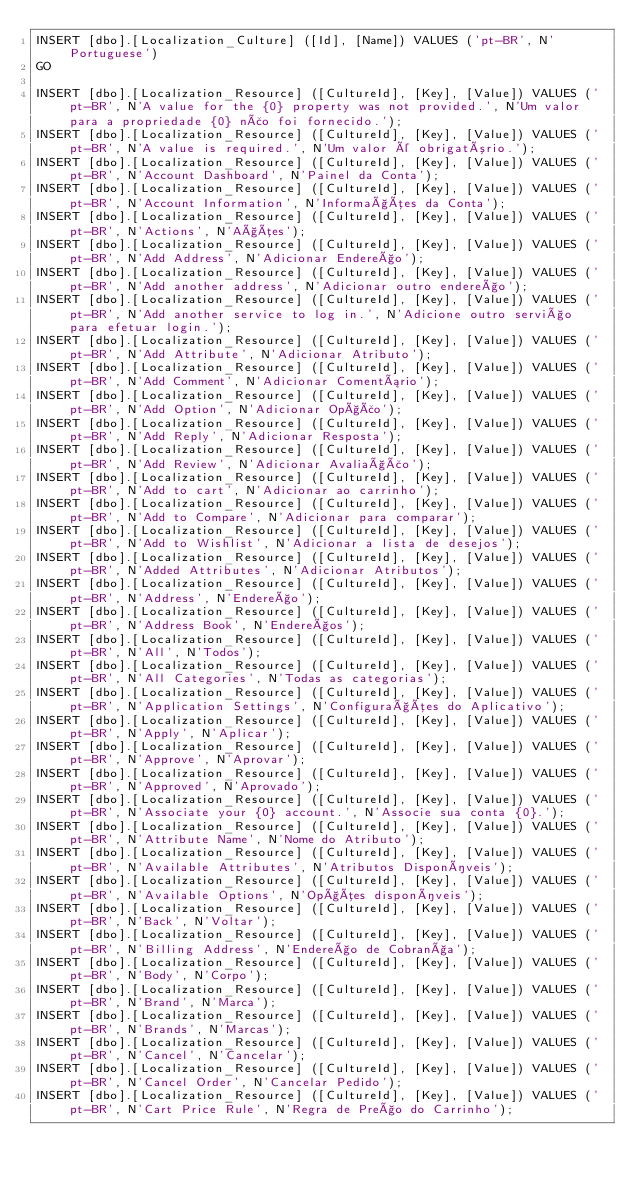Convert code to text. <code><loc_0><loc_0><loc_500><loc_500><_SQL_>INSERT [dbo].[Localization_Culture] ([Id], [Name]) VALUES ('pt-BR', N'Portuguese')
GO

INSERT [dbo].[Localization_Resource] ([CultureId], [Key], [Value]) VALUES ('pt-BR', N'A value for the {0} property was not provided.', N'Um valor para a propriedade {0} não foi fornecido.');
INSERT [dbo].[Localization_Resource] ([CultureId], [Key], [Value]) VALUES ('pt-BR', N'A value is required.', N'Um valor é obrigatório.');
INSERT [dbo].[Localization_Resource] ([CultureId], [Key], [Value]) VALUES ('pt-BR', N'Account Dashboard', N'Painel da Conta');
INSERT [dbo].[Localization_Resource] ([CultureId], [Key], [Value]) VALUES ('pt-BR', N'Account Information', N'Informações da Conta');
INSERT [dbo].[Localization_Resource] ([CultureId], [Key], [Value]) VALUES ('pt-BR', N'Actions', N'Ações');
INSERT [dbo].[Localization_Resource] ([CultureId], [Key], [Value]) VALUES ('pt-BR', N'Add Address', N'Adicionar Endereço');
INSERT [dbo].[Localization_Resource] ([CultureId], [Key], [Value]) VALUES ('pt-BR', N'Add another address', N'Adicionar outro endereço');
INSERT [dbo].[Localization_Resource] ([CultureId], [Key], [Value]) VALUES ('pt-BR', N'Add another service to log in.', N'Adicione outro serviço para efetuar login.');
INSERT [dbo].[Localization_Resource] ([CultureId], [Key], [Value]) VALUES ('pt-BR', N'Add Attribute', N'Adicionar Atributo');
INSERT [dbo].[Localization_Resource] ([CultureId], [Key], [Value]) VALUES ('pt-BR', N'Add Comment', N'Adicionar Comentário');
INSERT [dbo].[Localization_Resource] ([CultureId], [Key], [Value]) VALUES ('pt-BR', N'Add Option', N'Adicionar Opção');
INSERT [dbo].[Localization_Resource] ([CultureId], [Key], [Value]) VALUES ('pt-BR', N'Add Reply', N'Adicionar Resposta');
INSERT [dbo].[Localization_Resource] ([CultureId], [Key], [Value]) VALUES ('pt-BR', N'Add Review', N'Adicionar Avaliação');
INSERT [dbo].[Localization_Resource] ([CultureId], [Key], [Value]) VALUES ('pt-BR', N'Add to cart', N'Adicionar ao carrinho');
INSERT [dbo].[Localization_Resource] ([CultureId], [Key], [Value]) VALUES ('pt-BR', N'Add to Compare', N'Adicionar para comparar');
INSERT [dbo].[Localization_Resource] ([CultureId], [Key], [Value]) VALUES ('pt-BR', N'Add to Wishlist', N'Adicionar a lista de desejos');
INSERT [dbo].[Localization_Resource] ([CultureId], [Key], [Value]) VALUES ('pt-BR', N'Added Attributes', N'Adicionar Atributos');
INSERT [dbo].[Localization_Resource] ([CultureId], [Key], [Value]) VALUES ('pt-BR', N'Address', N'Endereço');
INSERT [dbo].[Localization_Resource] ([CultureId], [Key], [Value]) VALUES ('pt-BR', N'Address Book', N'Endereços');
INSERT [dbo].[Localization_Resource] ([CultureId], [Key], [Value]) VALUES ('pt-BR', N'All', N'Todos');
INSERT [dbo].[Localization_Resource] ([CultureId], [Key], [Value]) VALUES ('pt-BR', N'All Categories', N'Todas as categorias');
INSERT [dbo].[Localization_Resource] ([CultureId], [Key], [Value]) VALUES ('pt-BR', N'Application Settings', N'Configurações do Aplicativo');
INSERT [dbo].[Localization_Resource] ([CultureId], [Key], [Value]) VALUES ('pt-BR', N'Apply', N'Aplicar');
INSERT [dbo].[Localization_Resource] ([CultureId], [Key], [Value]) VALUES ('pt-BR', N'Approve', N'Aprovar');
INSERT [dbo].[Localization_Resource] ([CultureId], [Key], [Value]) VALUES ('pt-BR', N'Approved', N'Aprovado');
INSERT [dbo].[Localization_Resource] ([CultureId], [Key], [Value]) VALUES ('pt-BR', N'Associate your {0} account.', N'Associe sua conta {0}.');
INSERT [dbo].[Localization_Resource] ([CultureId], [Key], [Value]) VALUES ('pt-BR', N'Attribute Name', N'Nome do Atributo');
INSERT [dbo].[Localization_Resource] ([CultureId], [Key], [Value]) VALUES ('pt-BR', N'Available Attributes', N'Atributos Disponíveis');
INSERT [dbo].[Localization_Resource] ([CultureId], [Key], [Value]) VALUES ('pt-BR', N'Available Options', N'Opções disponíveis');
INSERT [dbo].[Localization_Resource] ([CultureId], [Key], [Value]) VALUES ('pt-BR', N'Back', N'Voltar');
INSERT [dbo].[Localization_Resource] ([CultureId], [Key], [Value]) VALUES ('pt-BR', N'Billing Address', N'Endereço de Cobrança');
INSERT [dbo].[Localization_Resource] ([CultureId], [Key], [Value]) VALUES ('pt-BR', N'Body', N'Corpo');
INSERT [dbo].[Localization_Resource] ([CultureId], [Key], [Value]) VALUES ('pt-BR', N'Brand', N'Marca');
INSERT [dbo].[Localization_Resource] ([CultureId], [Key], [Value]) VALUES ('pt-BR', N'Brands', N'Marcas');
INSERT [dbo].[Localization_Resource] ([CultureId], [Key], [Value]) VALUES ('pt-BR', N'Cancel', N'Cancelar');
INSERT [dbo].[Localization_Resource] ([CultureId], [Key], [Value]) VALUES ('pt-BR', N'Cancel Order', N'Cancelar Pedido');
INSERT [dbo].[Localization_Resource] ([CultureId], [Key], [Value]) VALUES ('pt-BR', N'Cart Price Rule', N'Regra de Preço do Carrinho');</code> 